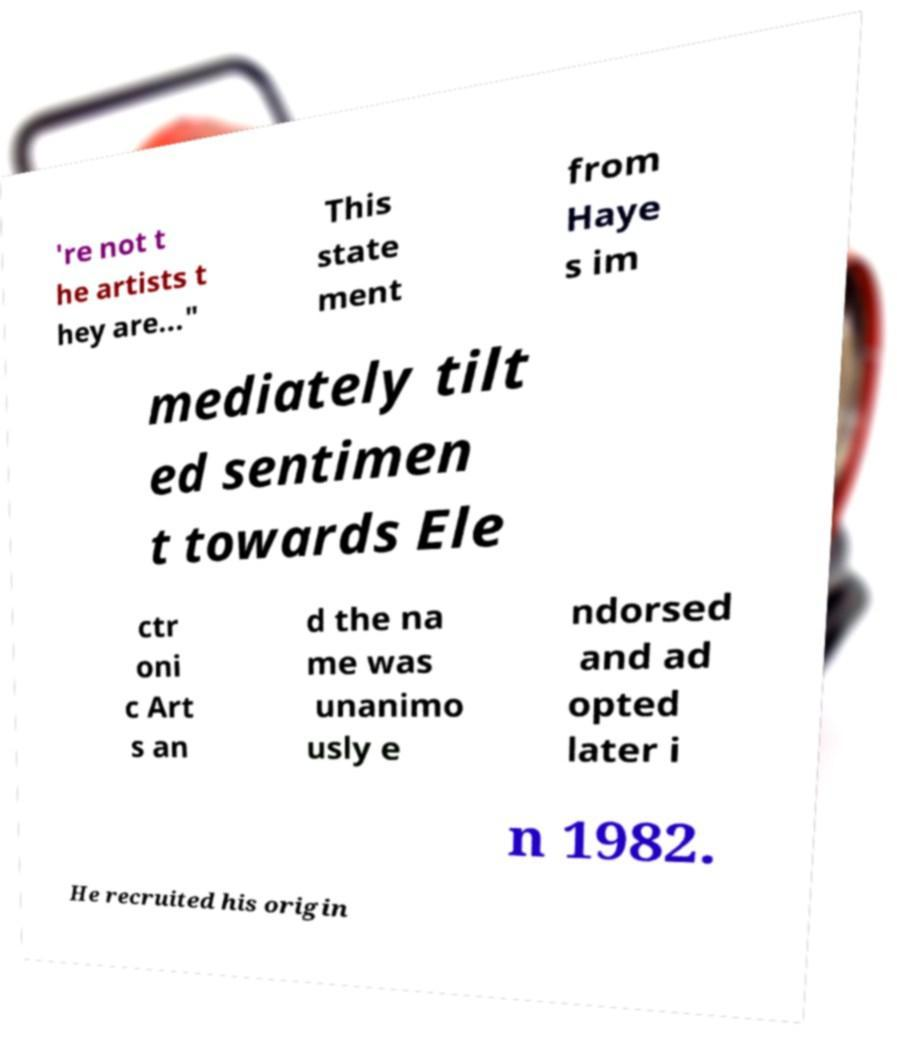For documentation purposes, I need the text within this image transcribed. Could you provide that? 're not t he artists t hey are..." This state ment from Haye s im mediately tilt ed sentimen t towards Ele ctr oni c Art s an d the na me was unanimo usly e ndorsed and ad opted later i n 1982. He recruited his origin 